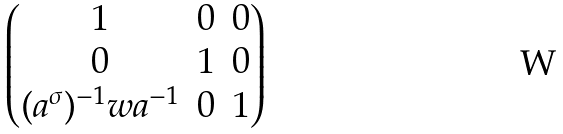<formula> <loc_0><loc_0><loc_500><loc_500>\begin{pmatrix} 1 & 0 & 0 \\ 0 & 1 & 0 \\ ( a ^ { \sigma } ) ^ { - 1 } w a ^ { - 1 } & 0 & 1 \end{pmatrix}</formula> 